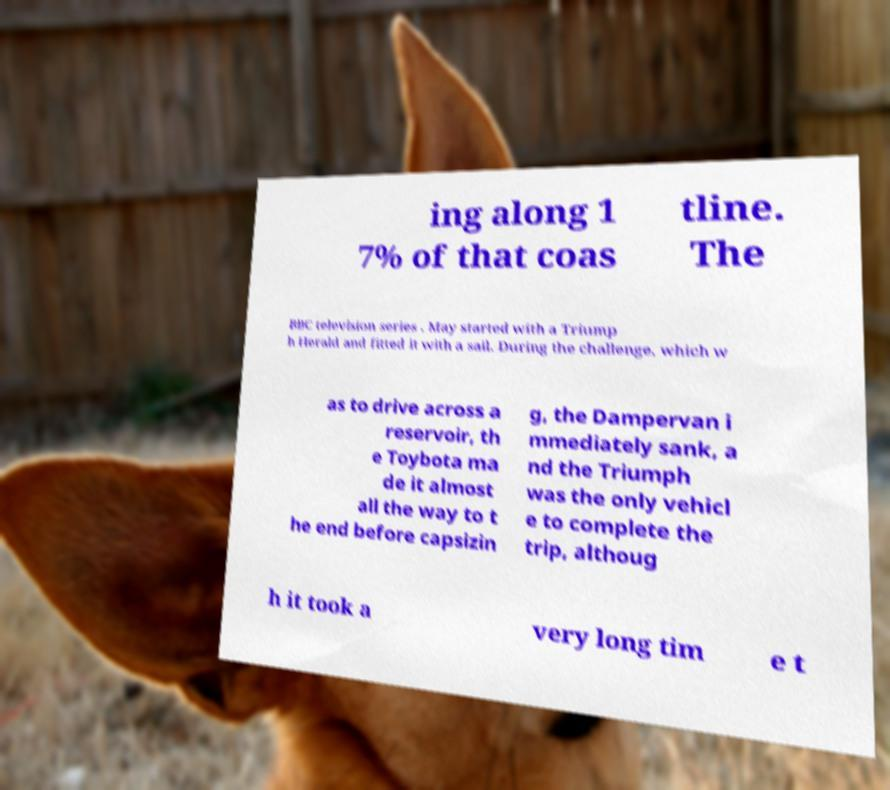I need the written content from this picture converted into text. Can you do that? ing along 1 7% of that coas tline. The BBC television series . May started with a Triump h Herald and fitted it with a sail. During the challenge, which w as to drive across a reservoir, th e Toybota ma de it almost all the way to t he end before capsizin g, the Dampervan i mmediately sank, a nd the Triumph was the only vehicl e to complete the trip, althoug h it took a very long tim e t 